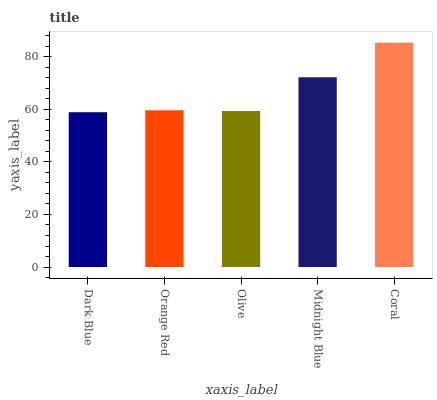Is Dark Blue the minimum?
Answer yes or no. Yes. Is Coral the maximum?
Answer yes or no. Yes. Is Orange Red the minimum?
Answer yes or no. No. Is Orange Red the maximum?
Answer yes or no. No. Is Orange Red greater than Dark Blue?
Answer yes or no. Yes. Is Dark Blue less than Orange Red?
Answer yes or no. Yes. Is Dark Blue greater than Orange Red?
Answer yes or no. No. Is Orange Red less than Dark Blue?
Answer yes or no. No. Is Orange Red the high median?
Answer yes or no. Yes. Is Orange Red the low median?
Answer yes or no. Yes. Is Coral the high median?
Answer yes or no. No. Is Midnight Blue the low median?
Answer yes or no. No. 